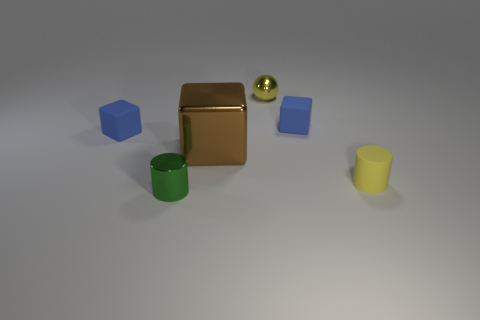There is a tiny blue matte object on the right side of the large shiny cube; what shape is it?
Keep it short and to the point. Cube. Is the big block made of the same material as the tiny yellow sphere?
Your response must be concise. Yes. Is there any other thing that is the same size as the metallic cube?
Make the answer very short. No. How many tiny cubes are in front of the large brown metal cube?
Your answer should be very brief. 0. There is a blue rubber object behind the tiny blue matte block that is on the left side of the small yellow ball; what shape is it?
Provide a succinct answer. Cube. Is there anything else that is the same shape as the yellow metal object?
Your response must be concise. No. Are there more cylinders on the right side of the tiny green shiny cylinder than big cyan rubber spheres?
Offer a terse response. Yes. How many big brown cubes are behind the brown metallic object that is to the right of the green metal cylinder?
Provide a succinct answer. 0. There is a tiny object left of the metallic object on the left side of the brown object right of the small green metallic object; what shape is it?
Your answer should be very brief. Cube. The brown metallic block is what size?
Offer a terse response. Large. 